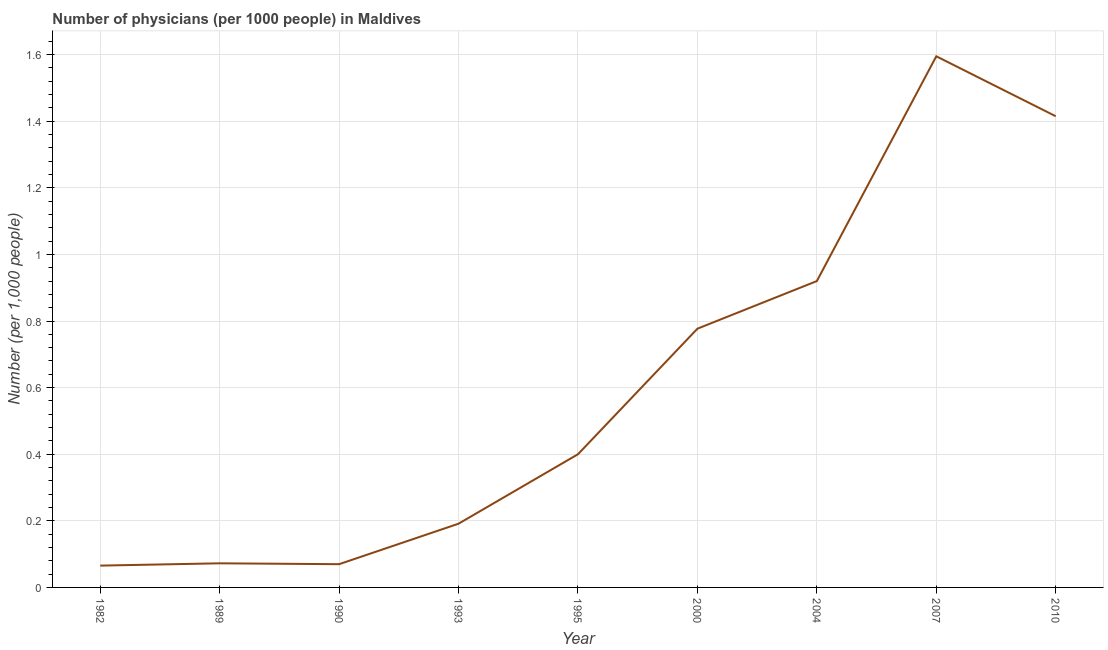Across all years, what is the maximum number of physicians?
Provide a succinct answer. 1.59. Across all years, what is the minimum number of physicians?
Your response must be concise. 0.07. In which year was the number of physicians maximum?
Ensure brevity in your answer.  2007. What is the sum of the number of physicians?
Your answer should be very brief. 5.51. What is the difference between the number of physicians in 1982 and 2010?
Provide a succinct answer. -1.35. What is the average number of physicians per year?
Provide a succinct answer. 0.61. What is the median number of physicians?
Your answer should be compact. 0.4. In how many years, is the number of physicians greater than 1.2400000000000002 ?
Give a very brief answer. 2. What is the ratio of the number of physicians in 1982 to that in 2004?
Ensure brevity in your answer.  0.07. Is the number of physicians in 1982 less than that in 1993?
Your response must be concise. Yes. What is the difference between the highest and the second highest number of physicians?
Keep it short and to the point. 0.18. What is the difference between the highest and the lowest number of physicians?
Ensure brevity in your answer.  1.53. In how many years, is the number of physicians greater than the average number of physicians taken over all years?
Provide a succinct answer. 4. Does the number of physicians monotonically increase over the years?
Your answer should be very brief. No. Does the graph contain grids?
Your answer should be very brief. Yes. What is the title of the graph?
Make the answer very short. Number of physicians (per 1000 people) in Maldives. What is the label or title of the X-axis?
Your response must be concise. Year. What is the label or title of the Y-axis?
Your response must be concise. Number (per 1,0 people). What is the Number (per 1,000 people) in 1982?
Offer a very short reply. 0.07. What is the Number (per 1,000 people) of 1989?
Offer a terse response. 0.07. What is the Number (per 1,000 people) in 1990?
Keep it short and to the point. 0.07. What is the Number (per 1,000 people) in 1993?
Provide a succinct answer. 0.19. What is the Number (per 1,000 people) of 2000?
Your answer should be very brief. 0.78. What is the Number (per 1,000 people) of 2007?
Offer a terse response. 1.59. What is the Number (per 1,000 people) of 2010?
Provide a succinct answer. 1.42. What is the difference between the Number (per 1,000 people) in 1982 and 1989?
Your answer should be compact. -0.01. What is the difference between the Number (per 1,000 people) in 1982 and 1990?
Provide a short and direct response. -0. What is the difference between the Number (per 1,000 people) in 1982 and 1993?
Make the answer very short. -0.13. What is the difference between the Number (per 1,000 people) in 1982 and 1995?
Offer a very short reply. -0.33. What is the difference between the Number (per 1,000 people) in 1982 and 2000?
Make the answer very short. -0.71. What is the difference between the Number (per 1,000 people) in 1982 and 2004?
Your answer should be very brief. -0.85. What is the difference between the Number (per 1,000 people) in 1982 and 2007?
Your answer should be compact. -1.53. What is the difference between the Number (per 1,000 people) in 1982 and 2010?
Make the answer very short. -1.35. What is the difference between the Number (per 1,000 people) in 1989 and 1990?
Your answer should be very brief. 0. What is the difference between the Number (per 1,000 people) in 1989 and 1993?
Offer a terse response. -0.12. What is the difference between the Number (per 1,000 people) in 1989 and 1995?
Make the answer very short. -0.33. What is the difference between the Number (per 1,000 people) in 1989 and 2000?
Your answer should be very brief. -0.7. What is the difference between the Number (per 1,000 people) in 1989 and 2004?
Make the answer very short. -0.85. What is the difference between the Number (per 1,000 people) in 1989 and 2007?
Give a very brief answer. -1.52. What is the difference between the Number (per 1,000 people) in 1989 and 2010?
Give a very brief answer. -1.34. What is the difference between the Number (per 1,000 people) in 1990 and 1993?
Offer a terse response. -0.12. What is the difference between the Number (per 1,000 people) in 1990 and 1995?
Make the answer very short. -0.33. What is the difference between the Number (per 1,000 people) in 1990 and 2000?
Your response must be concise. -0.71. What is the difference between the Number (per 1,000 people) in 1990 and 2004?
Provide a short and direct response. -0.85. What is the difference between the Number (per 1,000 people) in 1990 and 2007?
Give a very brief answer. -1.53. What is the difference between the Number (per 1,000 people) in 1990 and 2010?
Your response must be concise. -1.35. What is the difference between the Number (per 1,000 people) in 1993 and 1995?
Give a very brief answer. -0.21. What is the difference between the Number (per 1,000 people) in 1993 and 2000?
Your response must be concise. -0.59. What is the difference between the Number (per 1,000 people) in 1993 and 2004?
Your response must be concise. -0.73. What is the difference between the Number (per 1,000 people) in 1993 and 2007?
Your response must be concise. -1.4. What is the difference between the Number (per 1,000 people) in 1993 and 2010?
Offer a terse response. -1.22. What is the difference between the Number (per 1,000 people) in 1995 and 2000?
Offer a terse response. -0.38. What is the difference between the Number (per 1,000 people) in 1995 and 2004?
Keep it short and to the point. -0.52. What is the difference between the Number (per 1,000 people) in 1995 and 2007?
Give a very brief answer. -1.2. What is the difference between the Number (per 1,000 people) in 1995 and 2010?
Your response must be concise. -1.01. What is the difference between the Number (per 1,000 people) in 2000 and 2004?
Give a very brief answer. -0.14. What is the difference between the Number (per 1,000 people) in 2000 and 2007?
Ensure brevity in your answer.  -0.82. What is the difference between the Number (per 1,000 people) in 2000 and 2010?
Ensure brevity in your answer.  -0.64. What is the difference between the Number (per 1,000 people) in 2004 and 2007?
Your response must be concise. -0.68. What is the difference between the Number (per 1,000 people) in 2004 and 2010?
Your answer should be very brief. -0.49. What is the difference between the Number (per 1,000 people) in 2007 and 2010?
Ensure brevity in your answer.  0.18. What is the ratio of the Number (per 1,000 people) in 1982 to that in 1989?
Your answer should be very brief. 0.91. What is the ratio of the Number (per 1,000 people) in 1982 to that in 1990?
Give a very brief answer. 0.94. What is the ratio of the Number (per 1,000 people) in 1982 to that in 1993?
Your answer should be very brief. 0.34. What is the ratio of the Number (per 1,000 people) in 1982 to that in 1995?
Ensure brevity in your answer.  0.16. What is the ratio of the Number (per 1,000 people) in 1982 to that in 2000?
Make the answer very short. 0.08. What is the ratio of the Number (per 1,000 people) in 1982 to that in 2004?
Offer a very short reply. 0.07. What is the ratio of the Number (per 1,000 people) in 1982 to that in 2007?
Keep it short and to the point. 0.04. What is the ratio of the Number (per 1,000 people) in 1982 to that in 2010?
Provide a short and direct response. 0.05. What is the ratio of the Number (per 1,000 people) in 1989 to that in 1990?
Provide a short and direct response. 1.04. What is the ratio of the Number (per 1,000 people) in 1989 to that in 1993?
Your answer should be very brief. 0.38. What is the ratio of the Number (per 1,000 people) in 1989 to that in 1995?
Ensure brevity in your answer.  0.18. What is the ratio of the Number (per 1,000 people) in 1989 to that in 2000?
Give a very brief answer. 0.09. What is the ratio of the Number (per 1,000 people) in 1989 to that in 2004?
Provide a succinct answer. 0.08. What is the ratio of the Number (per 1,000 people) in 1989 to that in 2007?
Offer a very short reply. 0.04. What is the ratio of the Number (per 1,000 people) in 1989 to that in 2010?
Your response must be concise. 0.05. What is the ratio of the Number (per 1,000 people) in 1990 to that in 1993?
Provide a succinct answer. 0.36. What is the ratio of the Number (per 1,000 people) in 1990 to that in 1995?
Keep it short and to the point. 0.17. What is the ratio of the Number (per 1,000 people) in 1990 to that in 2000?
Your answer should be very brief. 0.09. What is the ratio of the Number (per 1,000 people) in 1990 to that in 2004?
Keep it short and to the point. 0.08. What is the ratio of the Number (per 1,000 people) in 1990 to that in 2007?
Your answer should be compact. 0.04. What is the ratio of the Number (per 1,000 people) in 1990 to that in 2010?
Ensure brevity in your answer.  0.05. What is the ratio of the Number (per 1,000 people) in 1993 to that in 1995?
Ensure brevity in your answer.  0.48. What is the ratio of the Number (per 1,000 people) in 1993 to that in 2000?
Keep it short and to the point. 0.25. What is the ratio of the Number (per 1,000 people) in 1993 to that in 2004?
Keep it short and to the point. 0.21. What is the ratio of the Number (per 1,000 people) in 1993 to that in 2007?
Provide a succinct answer. 0.12. What is the ratio of the Number (per 1,000 people) in 1993 to that in 2010?
Offer a very short reply. 0.14. What is the ratio of the Number (per 1,000 people) in 1995 to that in 2000?
Your response must be concise. 0.52. What is the ratio of the Number (per 1,000 people) in 1995 to that in 2004?
Offer a very short reply. 0.43. What is the ratio of the Number (per 1,000 people) in 1995 to that in 2007?
Ensure brevity in your answer.  0.25. What is the ratio of the Number (per 1,000 people) in 1995 to that in 2010?
Make the answer very short. 0.28. What is the ratio of the Number (per 1,000 people) in 2000 to that in 2004?
Make the answer very short. 0.84. What is the ratio of the Number (per 1,000 people) in 2000 to that in 2007?
Ensure brevity in your answer.  0.49. What is the ratio of the Number (per 1,000 people) in 2000 to that in 2010?
Your answer should be compact. 0.55. What is the ratio of the Number (per 1,000 people) in 2004 to that in 2007?
Offer a very short reply. 0.58. What is the ratio of the Number (per 1,000 people) in 2004 to that in 2010?
Offer a very short reply. 0.65. What is the ratio of the Number (per 1,000 people) in 2007 to that in 2010?
Provide a succinct answer. 1.13. 